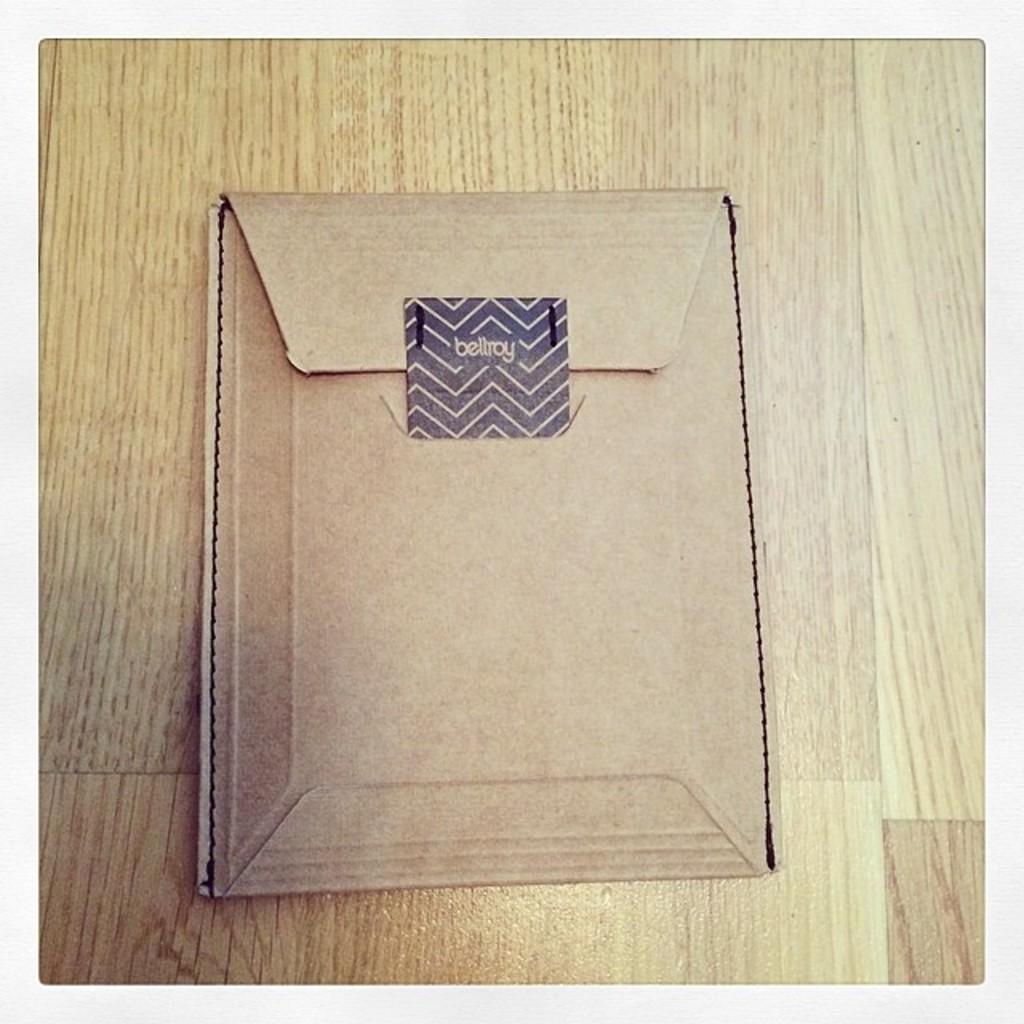What is in this package?
Keep it short and to the point. Unanswerable. 